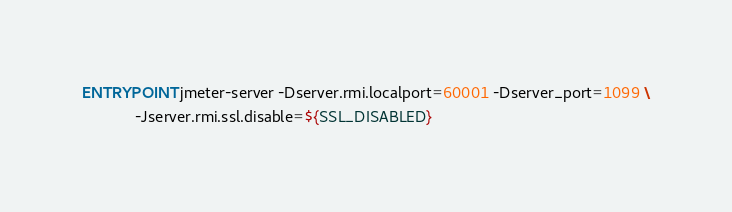Convert code to text. <code><loc_0><loc_0><loc_500><loc_500><_Dockerfile_>
ENTRYPOINT jmeter-server -Dserver.rmi.localport=60001 -Dserver_port=1099 \
            -Jserver.rmi.ssl.disable=${SSL_DISABLED}
</code> 